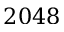Convert formula to latex. <formula><loc_0><loc_0><loc_500><loc_500>2 0 4 8</formula> 